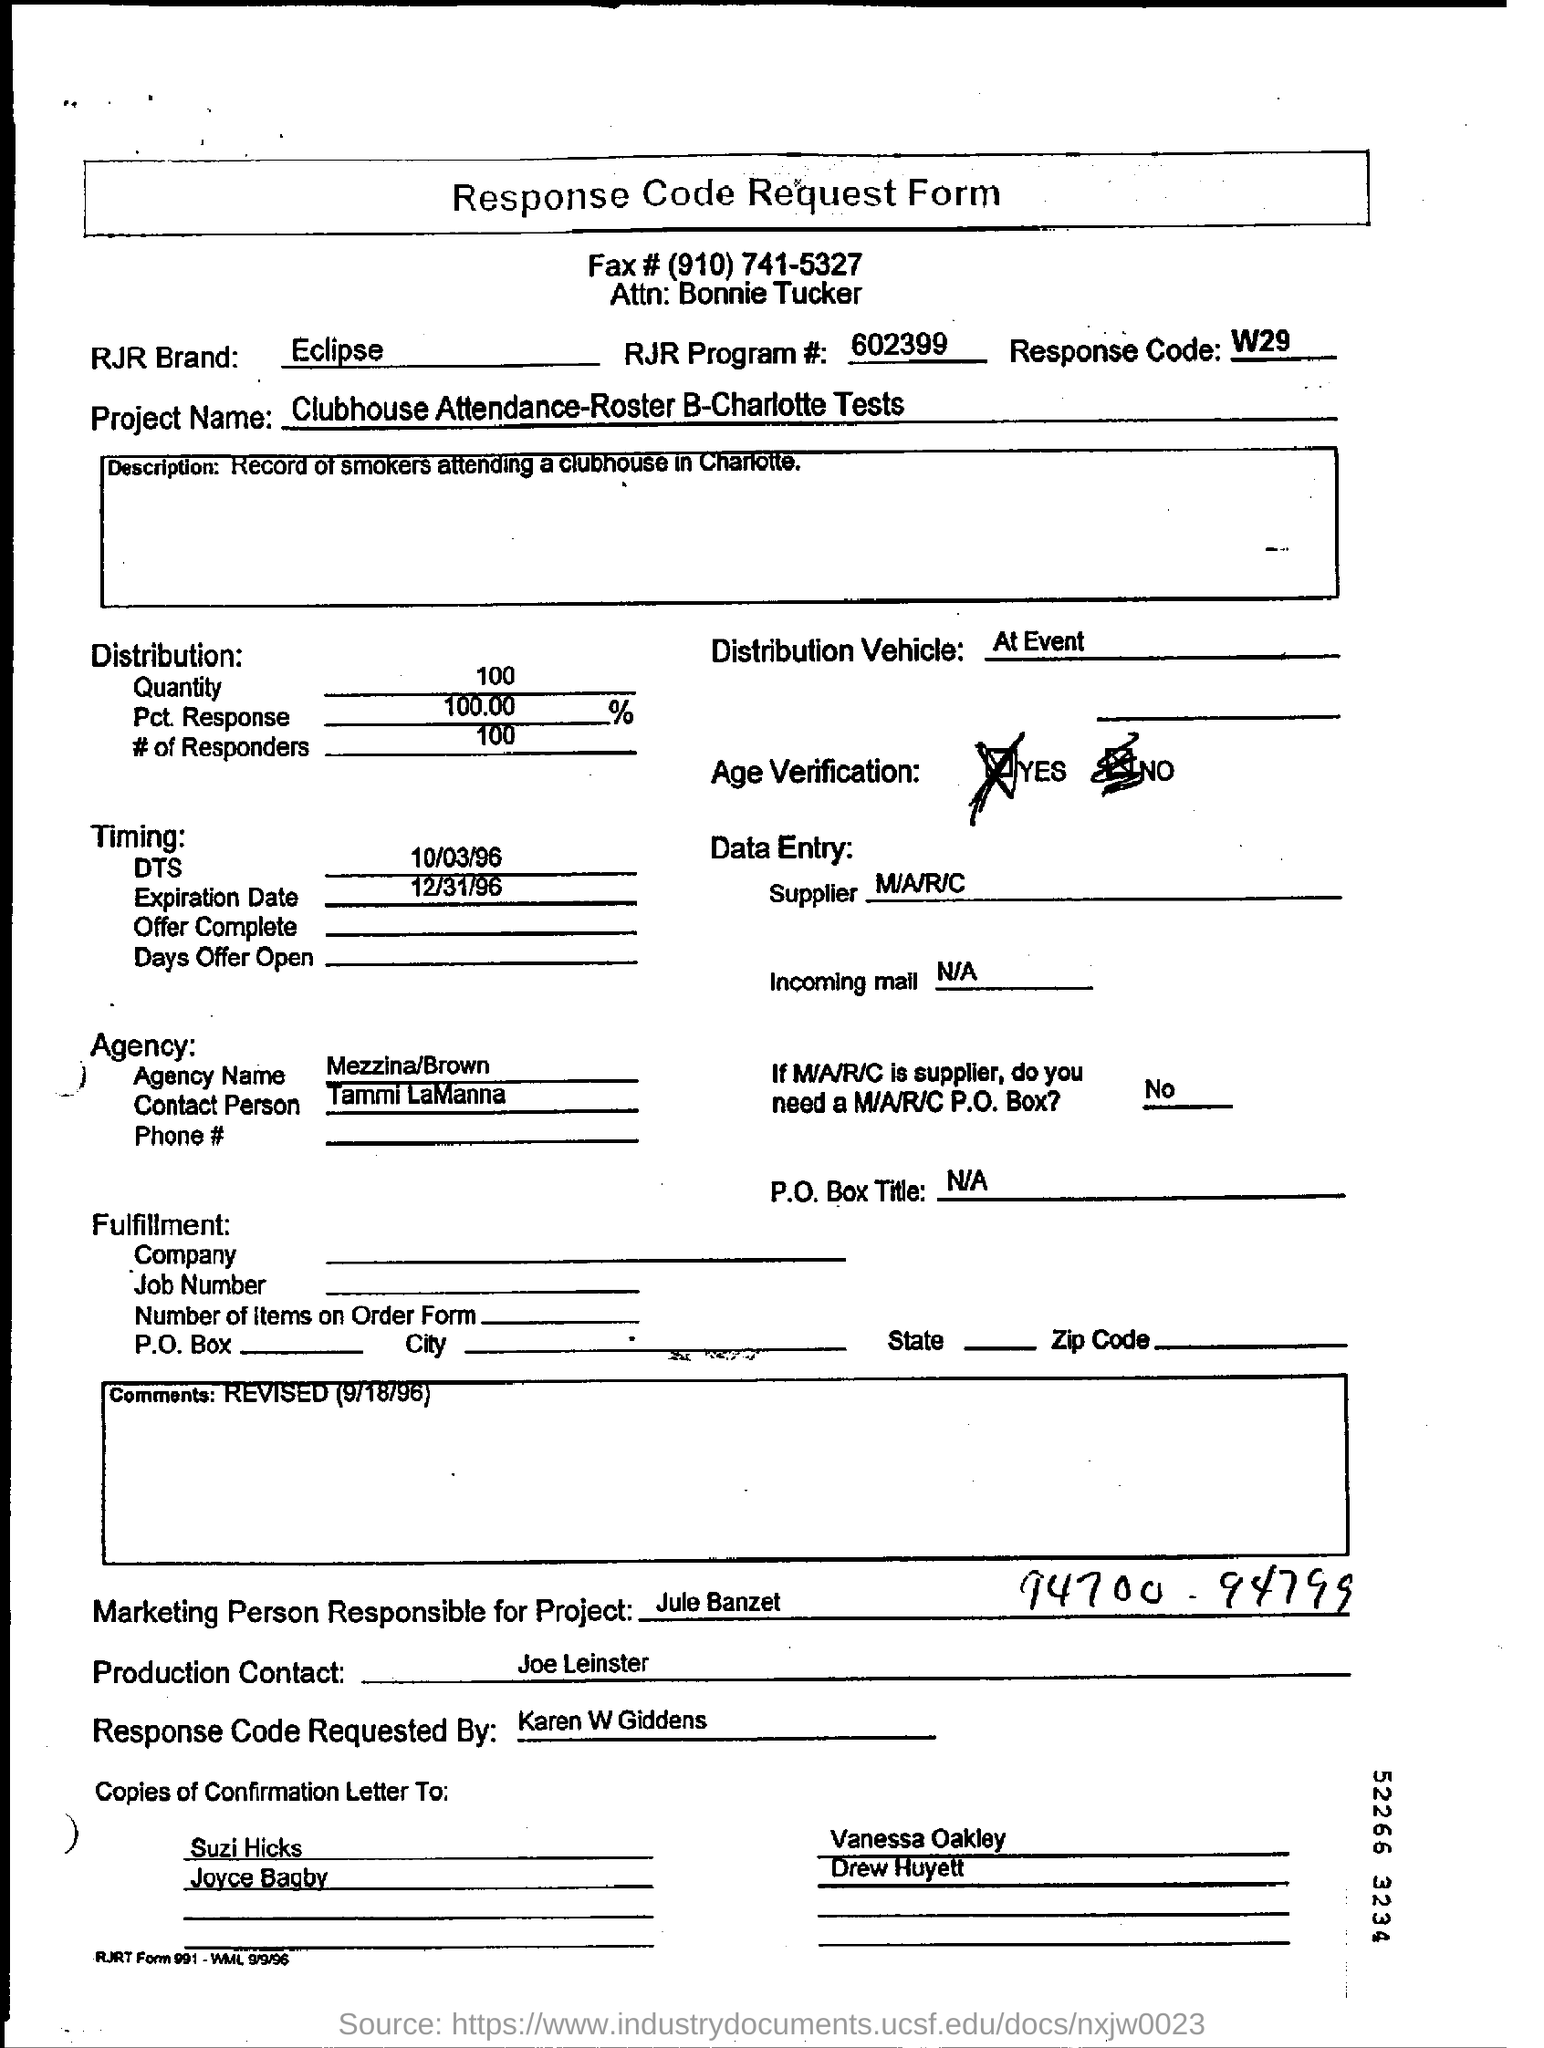List a handful of essential elements in this visual. Eclipse is the RJR Brand. The distribution quantity is 100... The contact person is TAMMI LAMANNA. The fax number is (910) 741-5327. The response code is W29. 